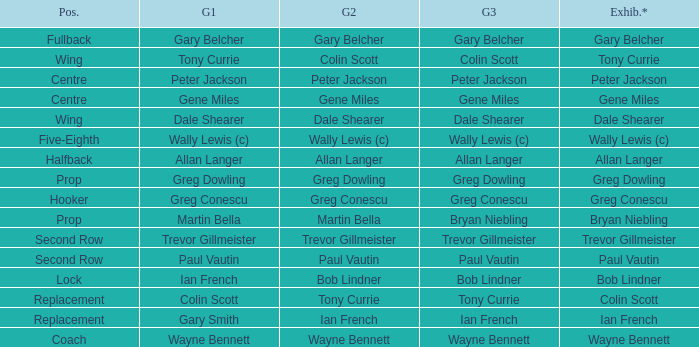Wjat game 3 has ian french as a game of 2? Ian French. 